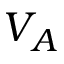Convert formula to latex. <formula><loc_0><loc_0><loc_500><loc_500>V _ { A }</formula> 